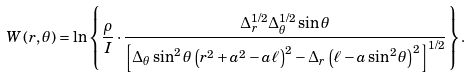Convert formula to latex. <formula><loc_0><loc_0><loc_500><loc_500>W \left ( r , \theta \right ) = \ln \left \{ \frac { \rho } { I } \cdot \frac { \Delta ^ { 1 / 2 } _ { r } \Delta ^ { 1 / 2 } _ { \theta } \sin \theta } { \left [ \Delta _ { \theta } \sin ^ { 2 } \theta \left ( r ^ { 2 } + a ^ { 2 } - a \ell \right ) ^ { 2 } - \Delta _ { r } \left ( \ell - a \sin ^ { 2 } \theta \right ) ^ { 2 } \right ] ^ { 1 / 2 } } \right \} .</formula> 